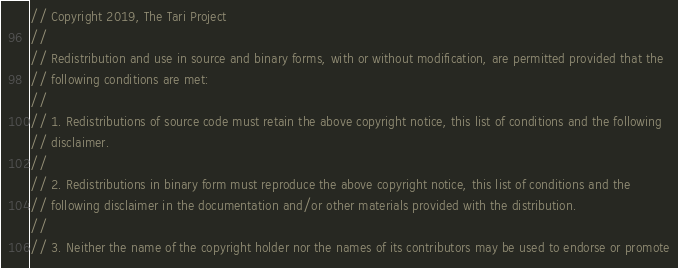<code> <loc_0><loc_0><loc_500><loc_500><_Rust_>// Copyright 2019, The Tari Project
//
// Redistribution and use in source and binary forms, with or without modification, are permitted provided that the
// following conditions are met:
//
// 1. Redistributions of source code must retain the above copyright notice, this list of conditions and the following
// disclaimer.
//
// 2. Redistributions in binary form must reproduce the above copyright notice, this list of conditions and the
// following disclaimer in the documentation and/or other materials provided with the distribution.
//
// 3. Neither the name of the copyright holder nor the names of its contributors may be used to endorse or promote</code> 